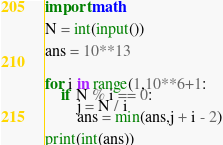<code> <loc_0><loc_0><loc_500><loc_500><_Python_>import math

N = int(input())

ans = 10**13


for i in range(1,10**6+1:
    if N % i == 0:
        j = N / i
        ans = min(ans,j + i - 2)
        
print(int(ans))</code> 